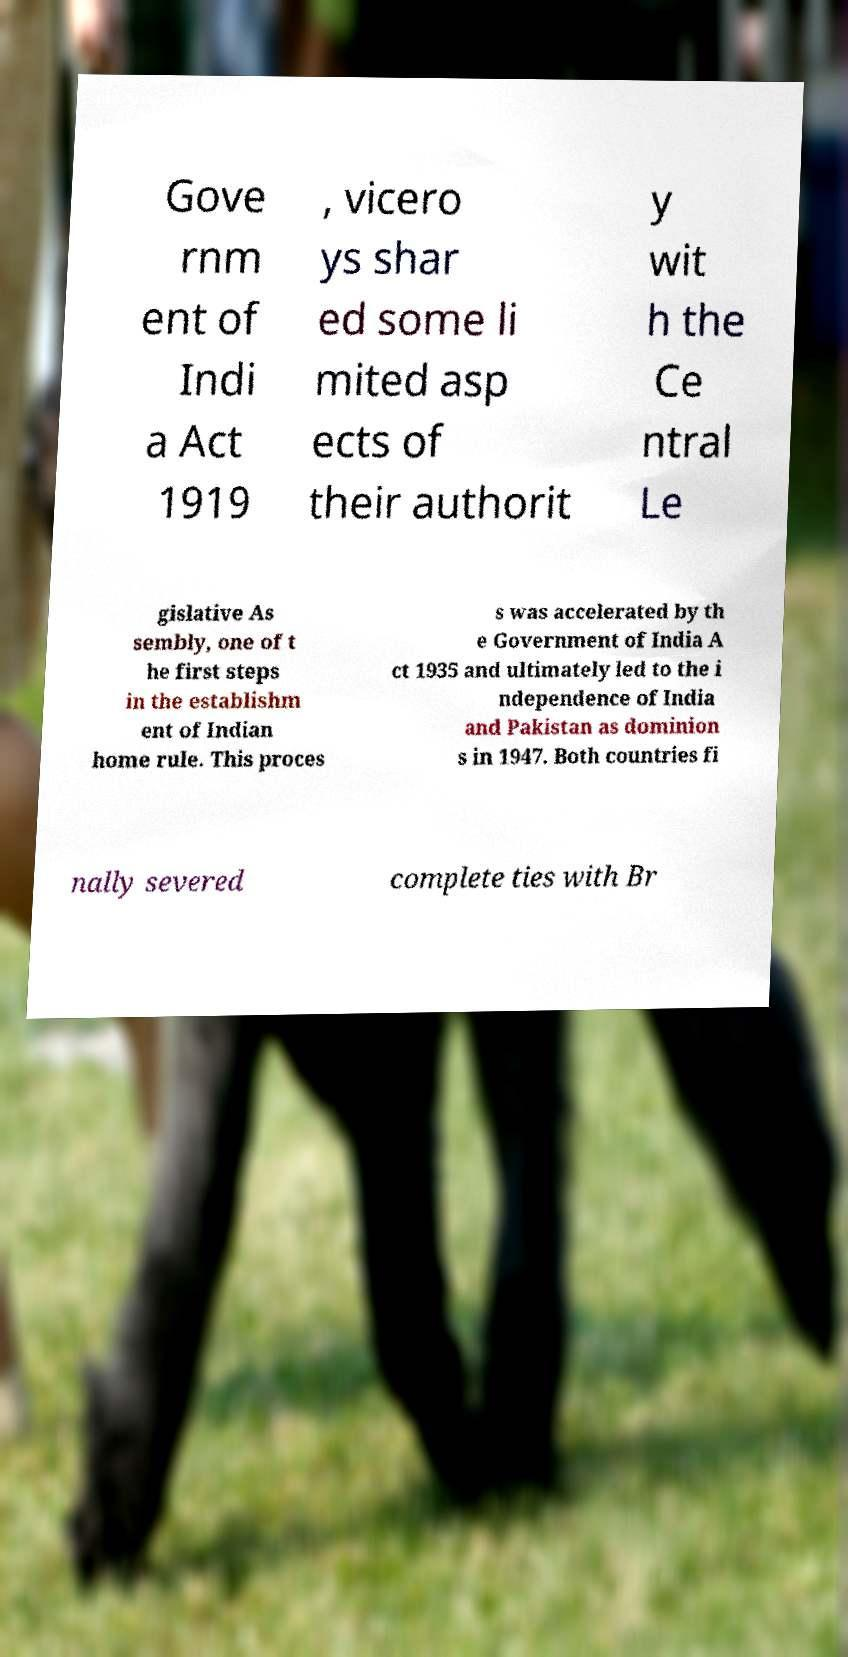Please read and relay the text visible in this image. What does it say? Gove rnm ent of Indi a Act 1919 , vicero ys shar ed some li mited asp ects of their authorit y wit h the Ce ntral Le gislative As sembly, one of t he first steps in the establishm ent of Indian home rule. This proces s was accelerated by th e Government of India A ct 1935 and ultimately led to the i ndependence of India and Pakistan as dominion s in 1947. Both countries fi nally severed complete ties with Br 